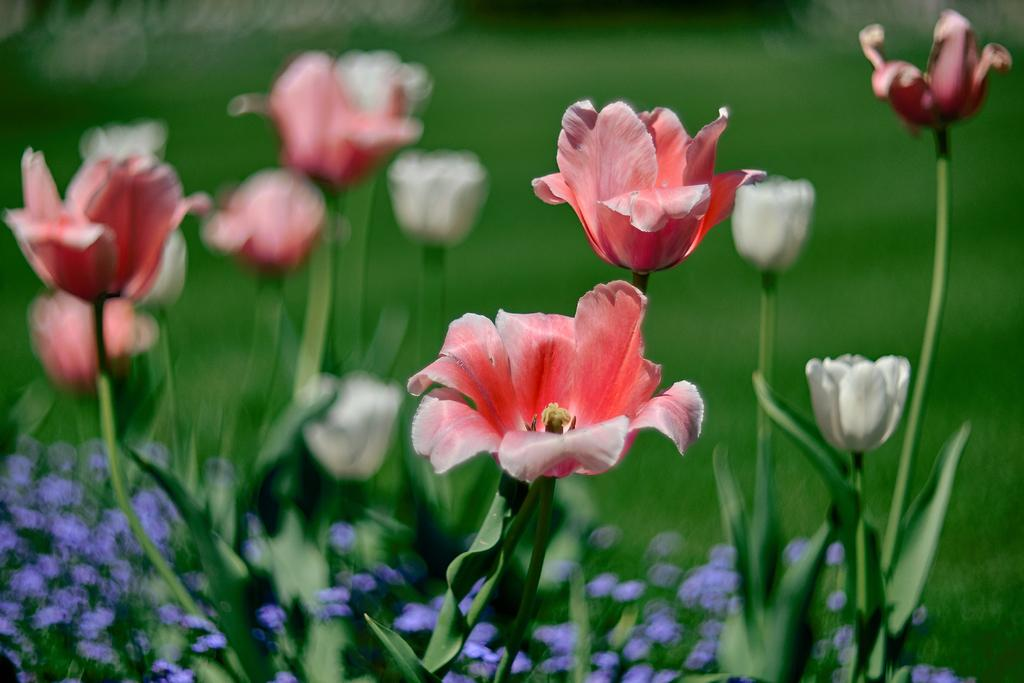What types of plants can be seen in the foreground of the image? There are plants and flowers in the foreground of the image. Can you describe the vegetation in the foreground? The vegetation in the foreground consists of plants and flowers. What type of ground cover is visible in the background of the image? There is grass visible in the background of the image. What type of thunder can be heard in the image? There is no sound present in the image, so it is not possible to determine if any thunder can be heard. 